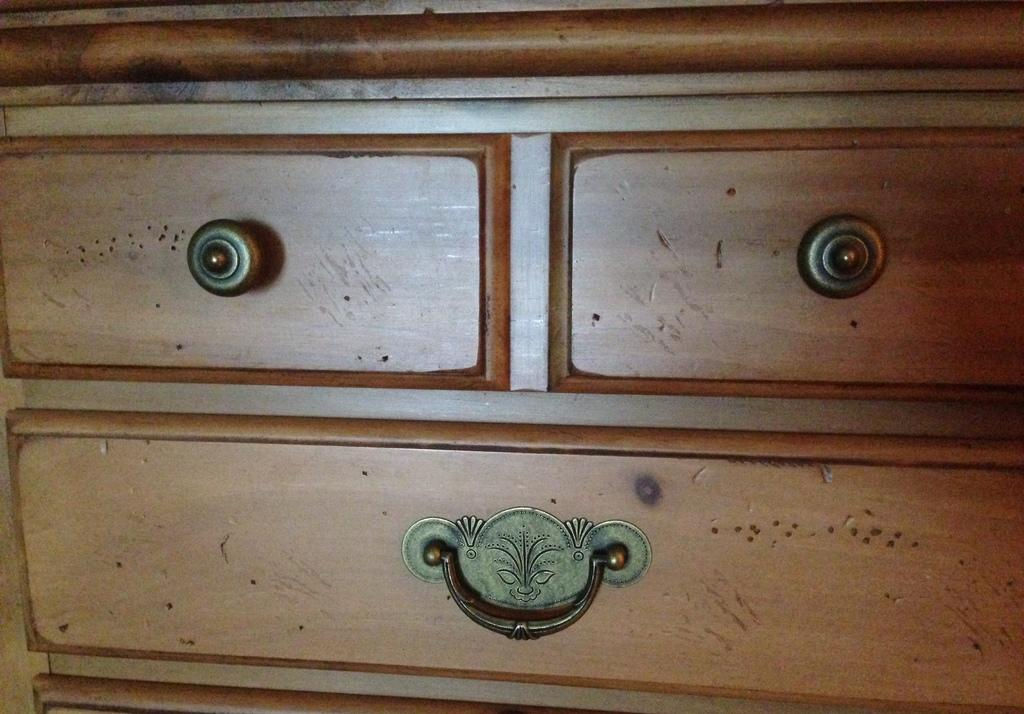What type of furniture is in the image? There is a cabinet in the image. What material is the cabinet made of? The cabinet is made of wood. How many drawers does the cabinet have? The cabinet has three drawers. What are the handles on the drawers made of? The handles on the drawers are made of metal. What is the purpose of the cabinet in downtown? The image does not specify the location of the cabinet as downtown, nor does it provide information about the purpose of the cabinet. 